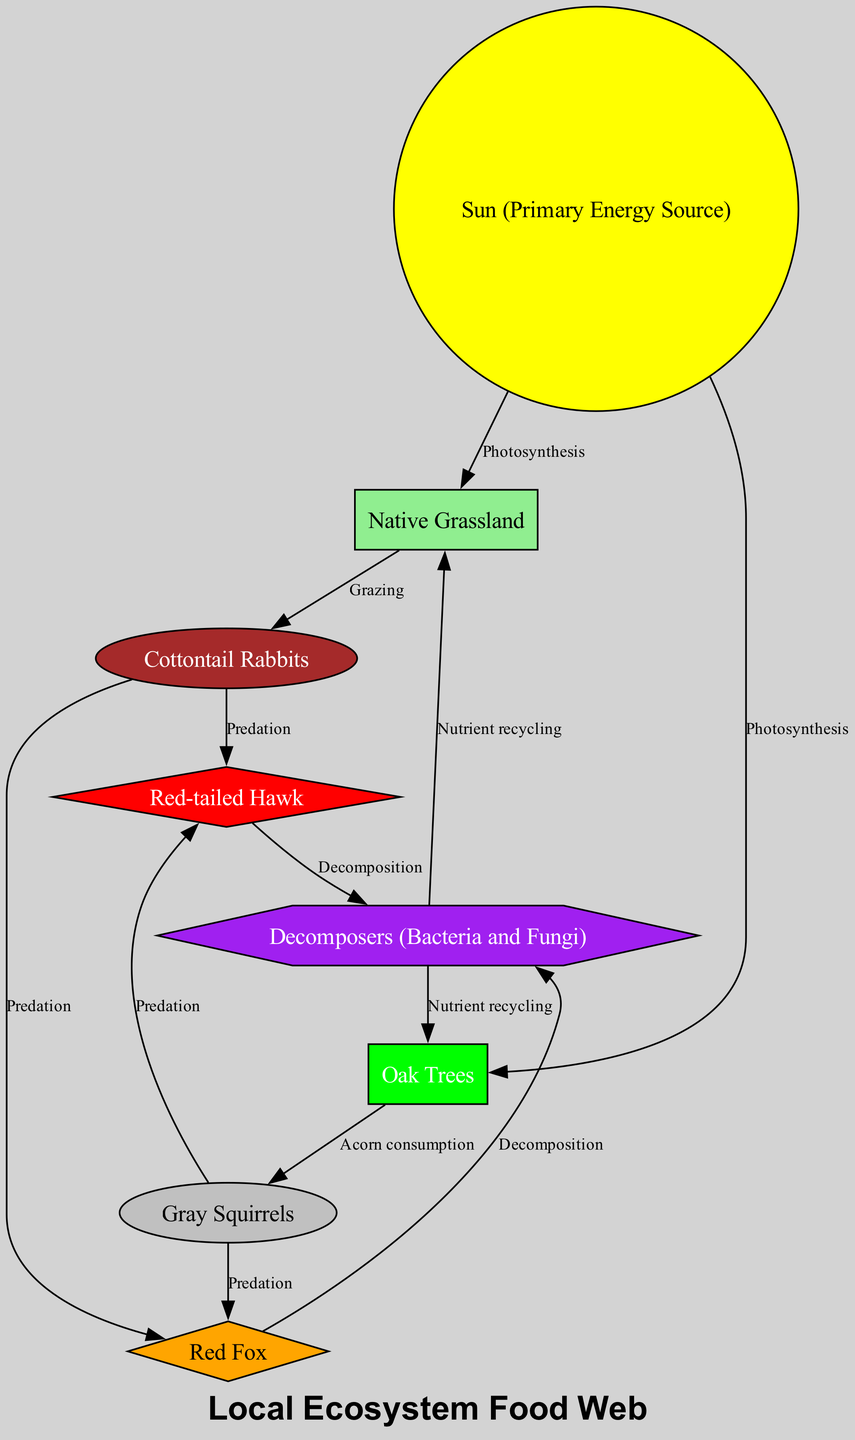What is the primary energy source in this ecosystem? The diagram shows that the "Sun" is labeled as the primary energy source for the ecosystem, as it is the origin of energy transfer indicated in the connections.
Answer: Sun (Primary Energy Source) How many types of plants are present in the diagram? The diagram includes two types of plants: "Native Grassland" and "Oak Trees," which suggests there are two distinct plant categories.
Answer: 2 Which animal preys on both rabbits and squirrels? Looking at the diagram, the "Red-tailed Hawk" is shown to have predation arrows leading from both "Cottontail Rabbits" and "Gray Squirrels," indicating it preys on these two animals.
Answer: Red-tailed Hawk What relationship connects the sun to the native grassland? The relationship connecting the "Sun" to "Native Grassland" is described by the term "Photosynthesis," which indicates the process through which plants utilize sunlight.
Answer: Photosynthesis How do decomposers contribute to the grass and oak trees? The "Decomposers" are shown to connect to both the "Grass" and "Oak Trees," and are labeled with "Nutrient recycling," highlighting their role in breaking down organic material and returning nutrients to these plants.
Answer: Nutrient recycling What type of organisms are represented as decomposers? The diagram specifies that "Bacteria and Fungi" are the types of organisms depicted as decomposers, responsible for breakdown and nutrient cycling.
Answer: Bacteria and Fungi Who are the primary consumers in this food web? The primary consumers in this food web are indicated by the arrows leading from "Native Grassland" to "Cottontail Rabbits" and from "Oak Trees" to "Gray Squirrels," showing they directly consume plants.
Answer: Cottontail Rabbits and Gray Squirrels What processes are identified for energy transfer from animals to decomposers? The diagram illustrates the processes of "Decomposition" leading from both "Red-tailed Hawk" and "Red Fox" to "Decomposers," indicating the energy transfer through dead organic matter.
Answer: Decomposition How many predation relationships are depicted in the diagram? The diagram shows a total of four predation relationships: Rabbits to Hawks, Rabbits to Foxes, Squirrels to Hawks, and Squirrels to Foxes, which totals to four connections.
Answer: 4 